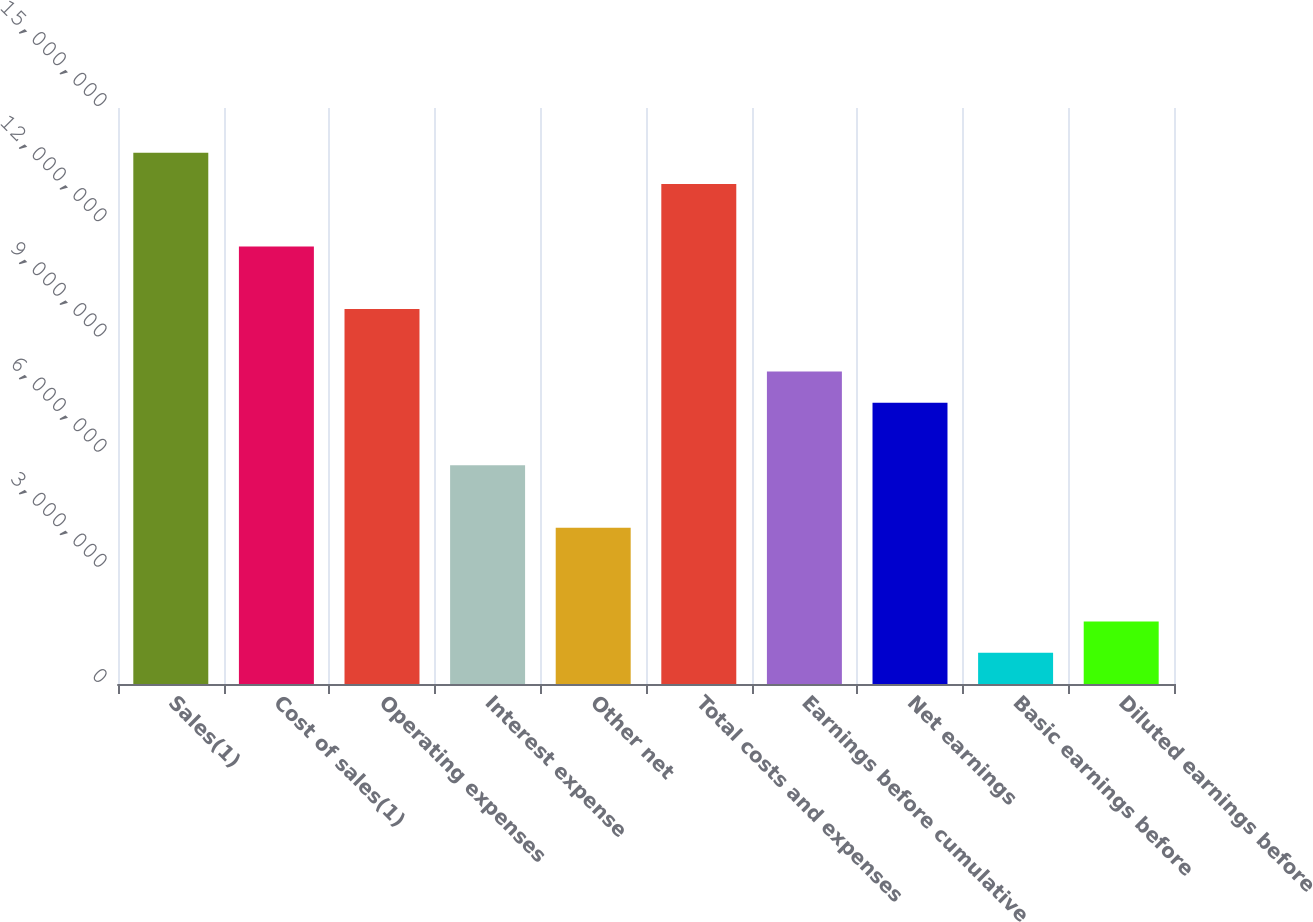<chart> <loc_0><loc_0><loc_500><loc_500><bar_chart><fcel>Sales(1)<fcel>Cost of sales(1)<fcel>Operating expenses<fcel>Interest expense<fcel>Other net<fcel>Total costs and expenses<fcel>Earnings before cumulative<fcel>Net earnings<fcel>Basic earnings before<fcel>Diluted earnings before<nl><fcel>1.38343e+07<fcel>1.13929e+07<fcel>9.76538e+06<fcel>5.69647e+06<fcel>4.06891e+06<fcel>1.30205e+07<fcel>8.13782e+06<fcel>7.32403e+06<fcel>813782<fcel>1.62756e+06<nl></chart> 